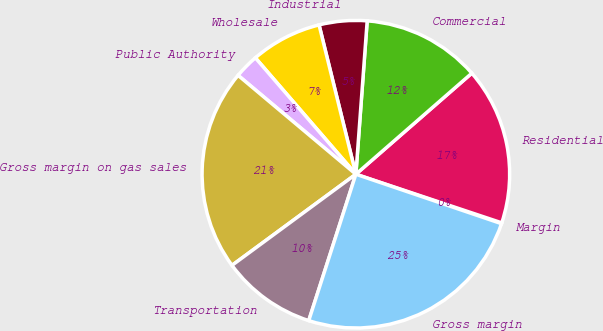Convert chart to OTSL. <chart><loc_0><loc_0><loc_500><loc_500><pie_chart><fcel>Margin<fcel>Residential<fcel>Commercial<fcel>Industrial<fcel>Wholesale<fcel>Public Authority<fcel>Gross margin on gas sales<fcel>Transportation<fcel>Gross margin<nl><fcel>0.09%<fcel>16.53%<fcel>12.42%<fcel>5.02%<fcel>7.49%<fcel>2.55%<fcel>21.21%<fcel>9.95%<fcel>24.75%<nl></chart> 